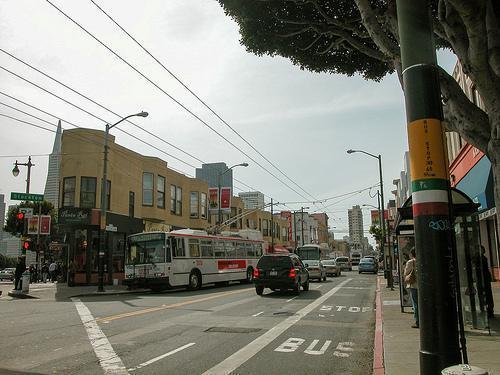How many red lights are in the picture?
Give a very brief answer. 5. 